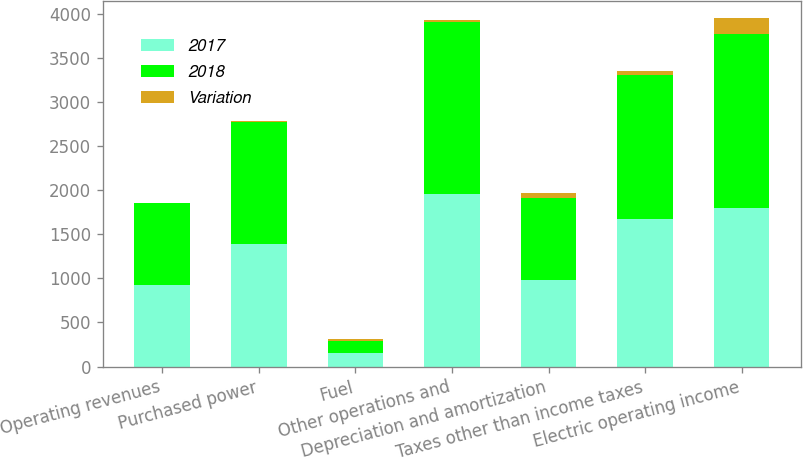Convert chart. <chart><loc_0><loc_0><loc_500><loc_500><stacked_bar_chart><ecel><fcel>Operating revenues<fcel>Purchased power<fcel>Fuel<fcel>Other operations and<fcel>Depreciation and amortization<fcel>Taxes other than income taxes<fcel>Electric operating income<nl><fcel>2017<fcel>925<fcel>1393<fcel>158<fcel>1961<fcel>984<fcel>1676<fcel>1799<nl><fcel>2018<fcel>925<fcel>1379<fcel>127<fcel>1942<fcel>925<fcel>1625<fcel>1974<nl><fcel>Variation<fcel>1<fcel>14<fcel>31<fcel>19<fcel>59<fcel>51<fcel>175<nl></chart> 